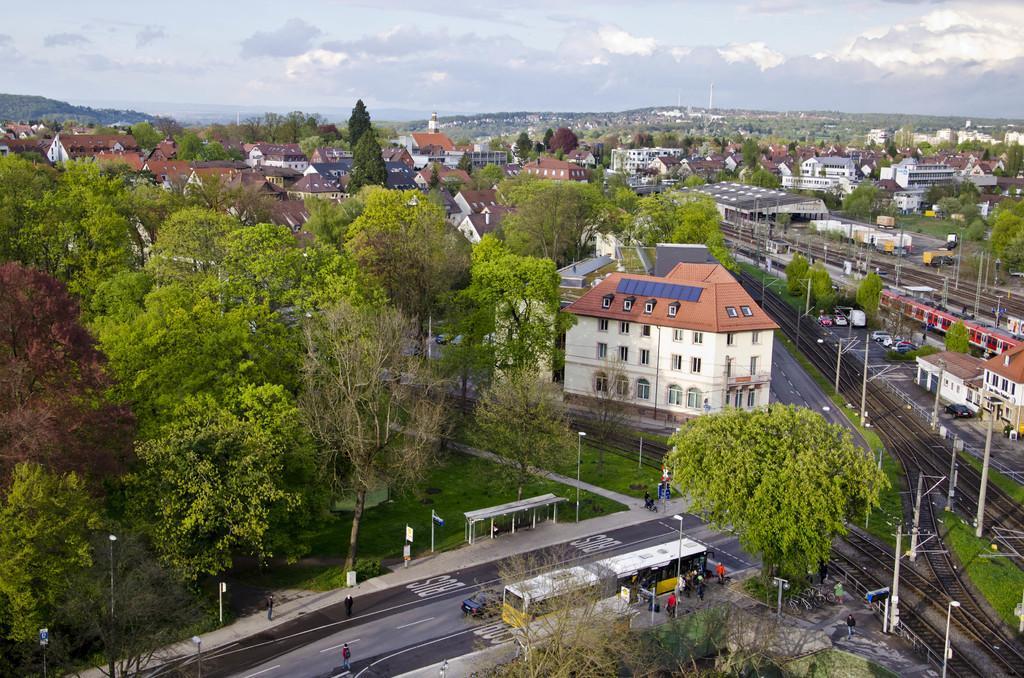How would you summarize this image in a sentence or two? In this picture we can see so many buildings, some vehicles are moving on the road, railway track and some trees. This picture is taken from top view. 